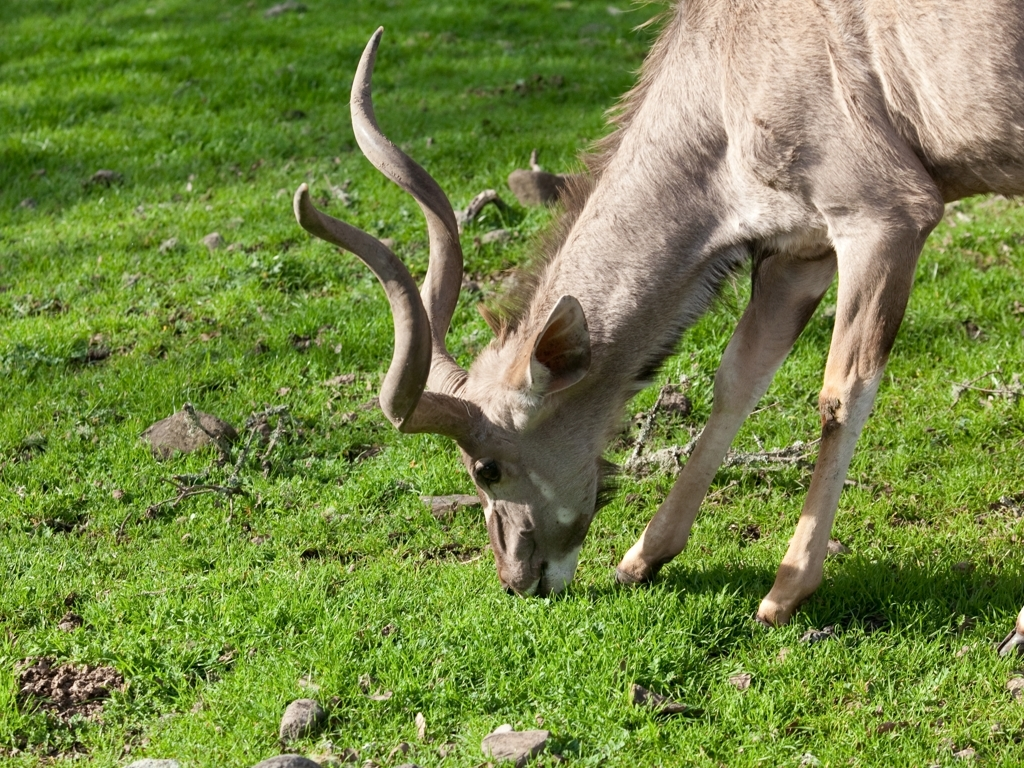Does the photo suffer from any noise or graininess?
 No 